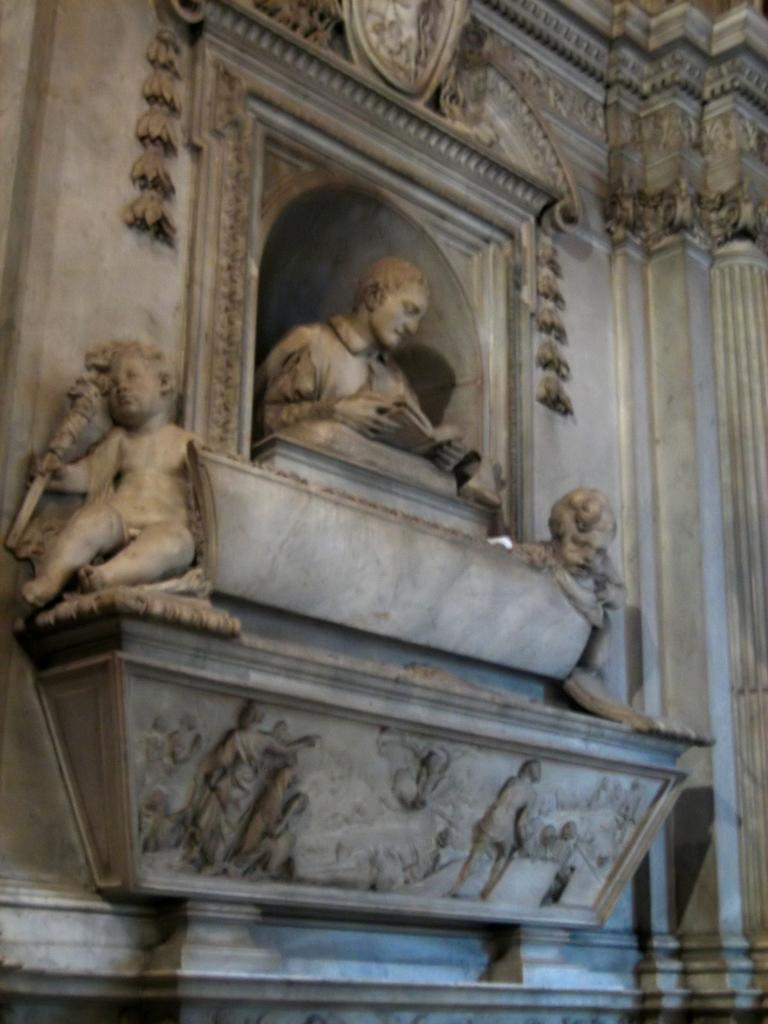What type of objects are depicted as statues in the image? There are statues of human beings in the image. What can be seen on the wall in the image? There are designs carved on the wall in the image. What type of clothing is the scarecrow wearing in the image? There is no scarecrow present in the image; it features statues of human beings and designs carved on the wall. 